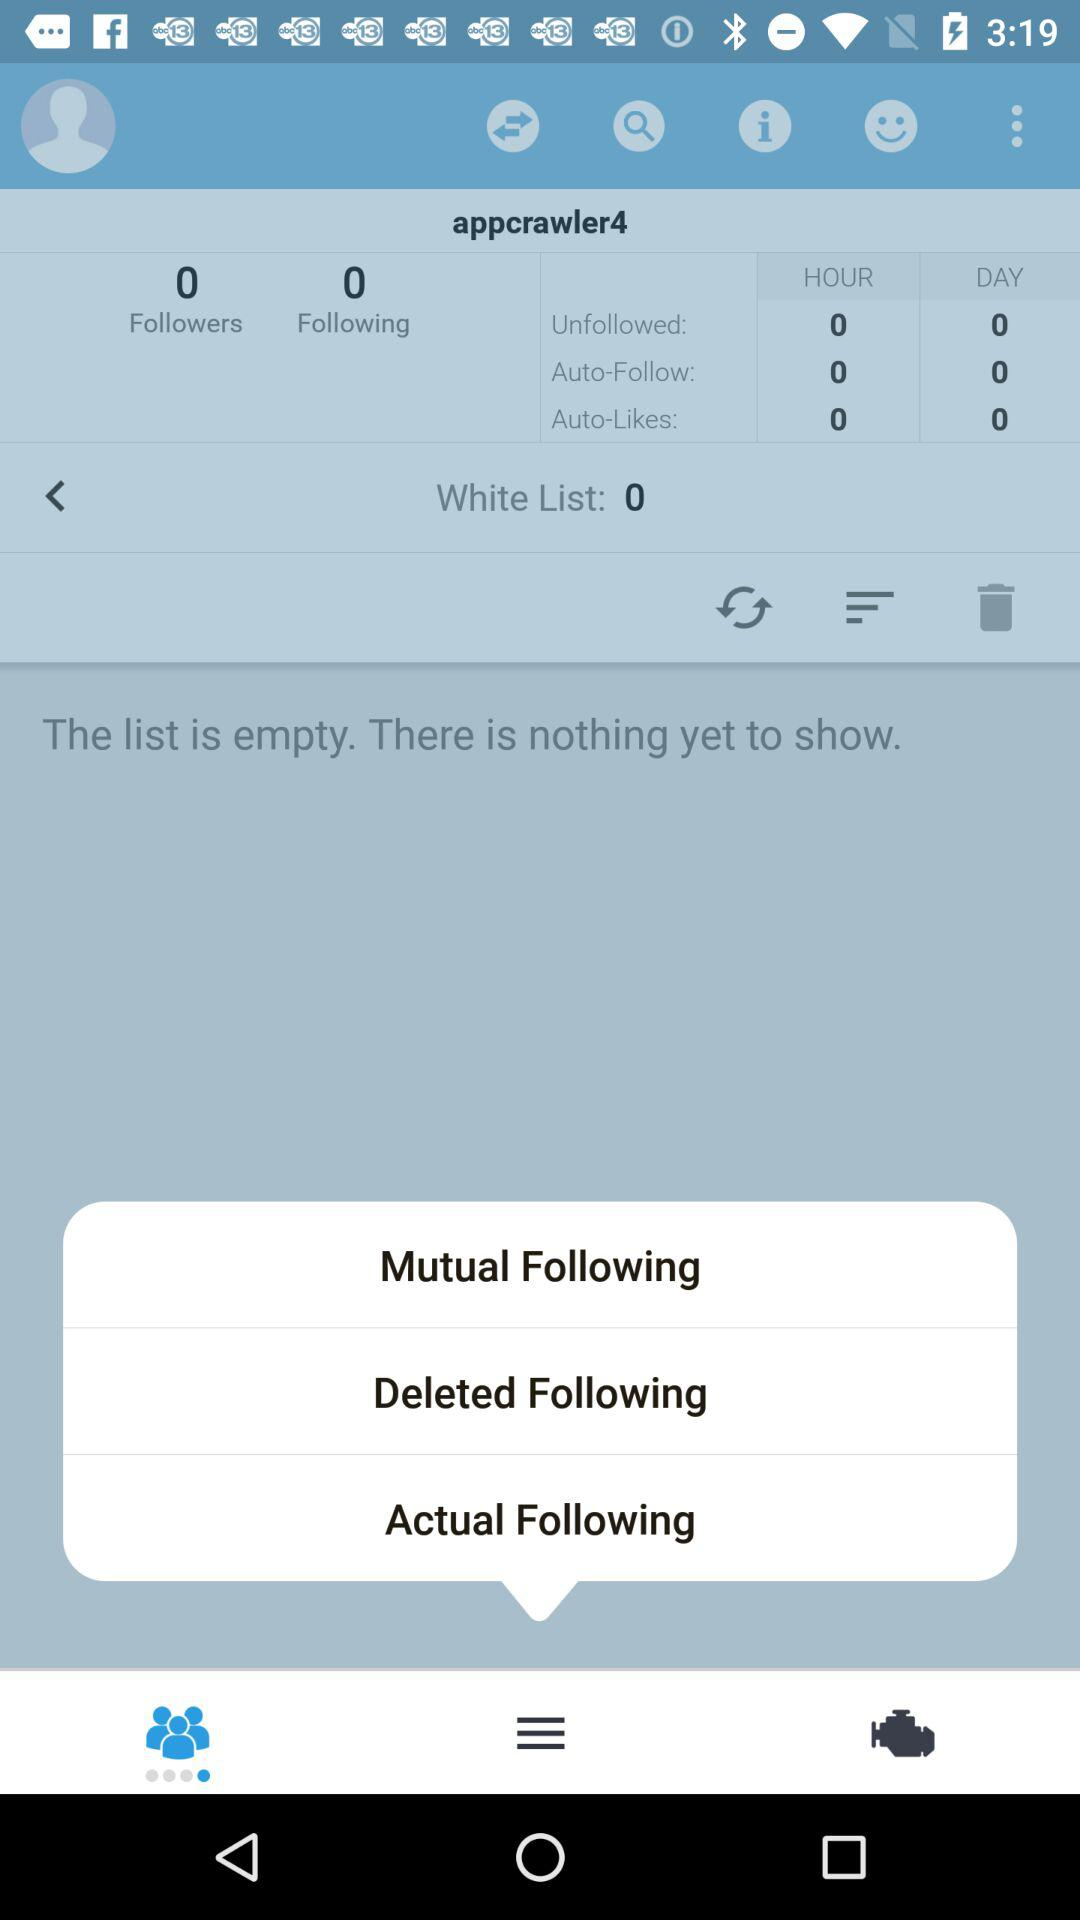How many followers are there? There are 0 followers. 